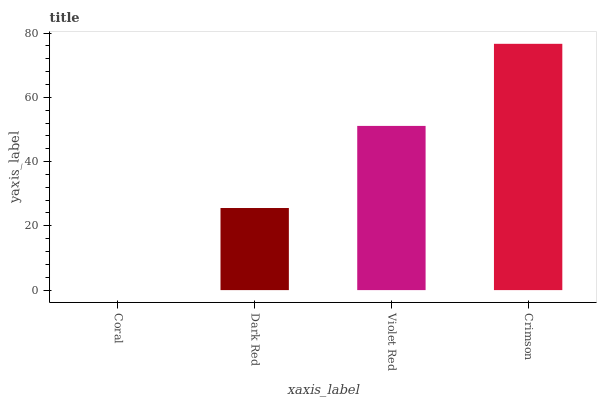Is Coral the minimum?
Answer yes or no. Yes. Is Crimson the maximum?
Answer yes or no. Yes. Is Dark Red the minimum?
Answer yes or no. No. Is Dark Red the maximum?
Answer yes or no. No. Is Dark Red greater than Coral?
Answer yes or no. Yes. Is Coral less than Dark Red?
Answer yes or no. Yes. Is Coral greater than Dark Red?
Answer yes or no. No. Is Dark Red less than Coral?
Answer yes or no. No. Is Violet Red the high median?
Answer yes or no. Yes. Is Dark Red the low median?
Answer yes or no. Yes. Is Crimson the high median?
Answer yes or no. No. Is Crimson the low median?
Answer yes or no. No. 